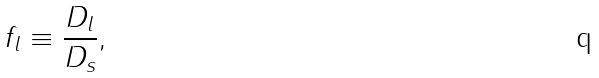Convert formula to latex. <formula><loc_0><loc_0><loc_500><loc_500>f _ { l } \equiv \frac { D _ { l } } { D _ { s } } ,</formula> 